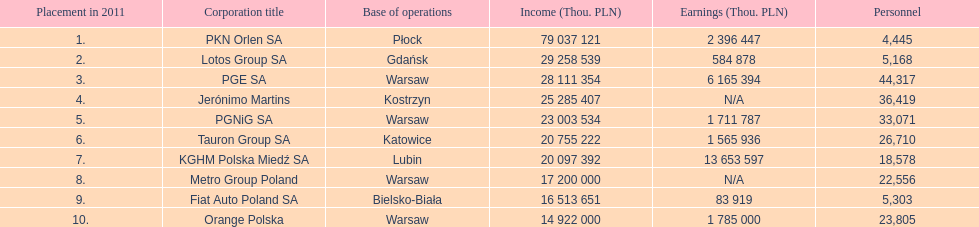What company has the top number of employees? PGE SA. 